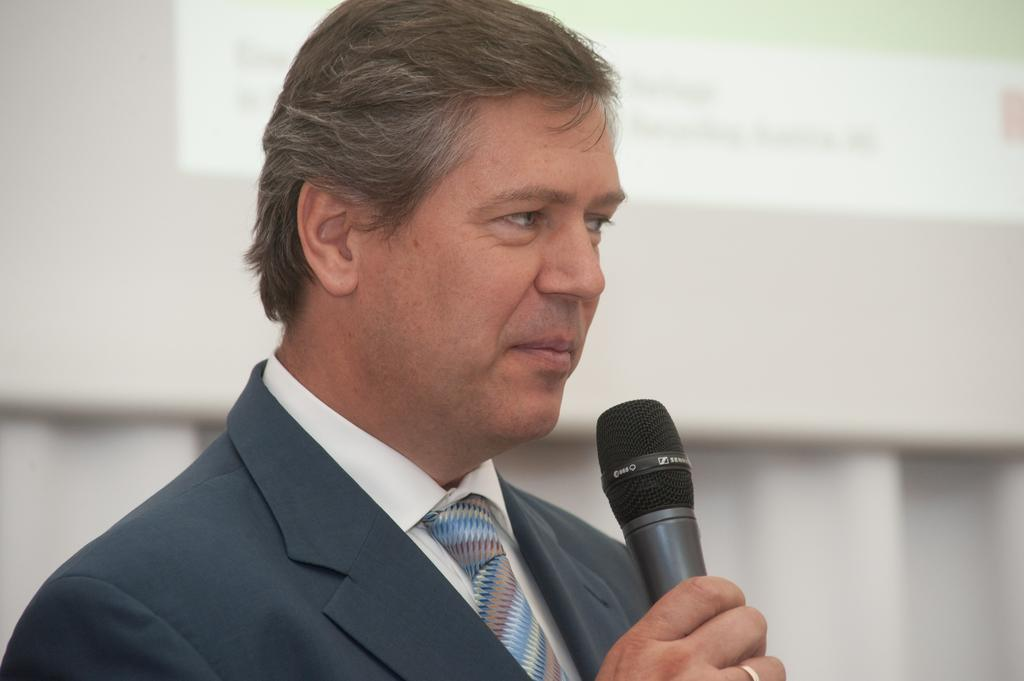What is the main subject of the image? There is a person in the image. What is the person wearing? The person is wearing a blue suit. What is the person holding in their right hand? The person is holding a microphone in their right hand. What color is the background of the image? The background of the image is white in color. How many chickens can be seen in the image? There are no chickens present in the image. What type of bead is being used to rub on the person's suit in the image? There is no bead or rubbing action depicted in the image. 